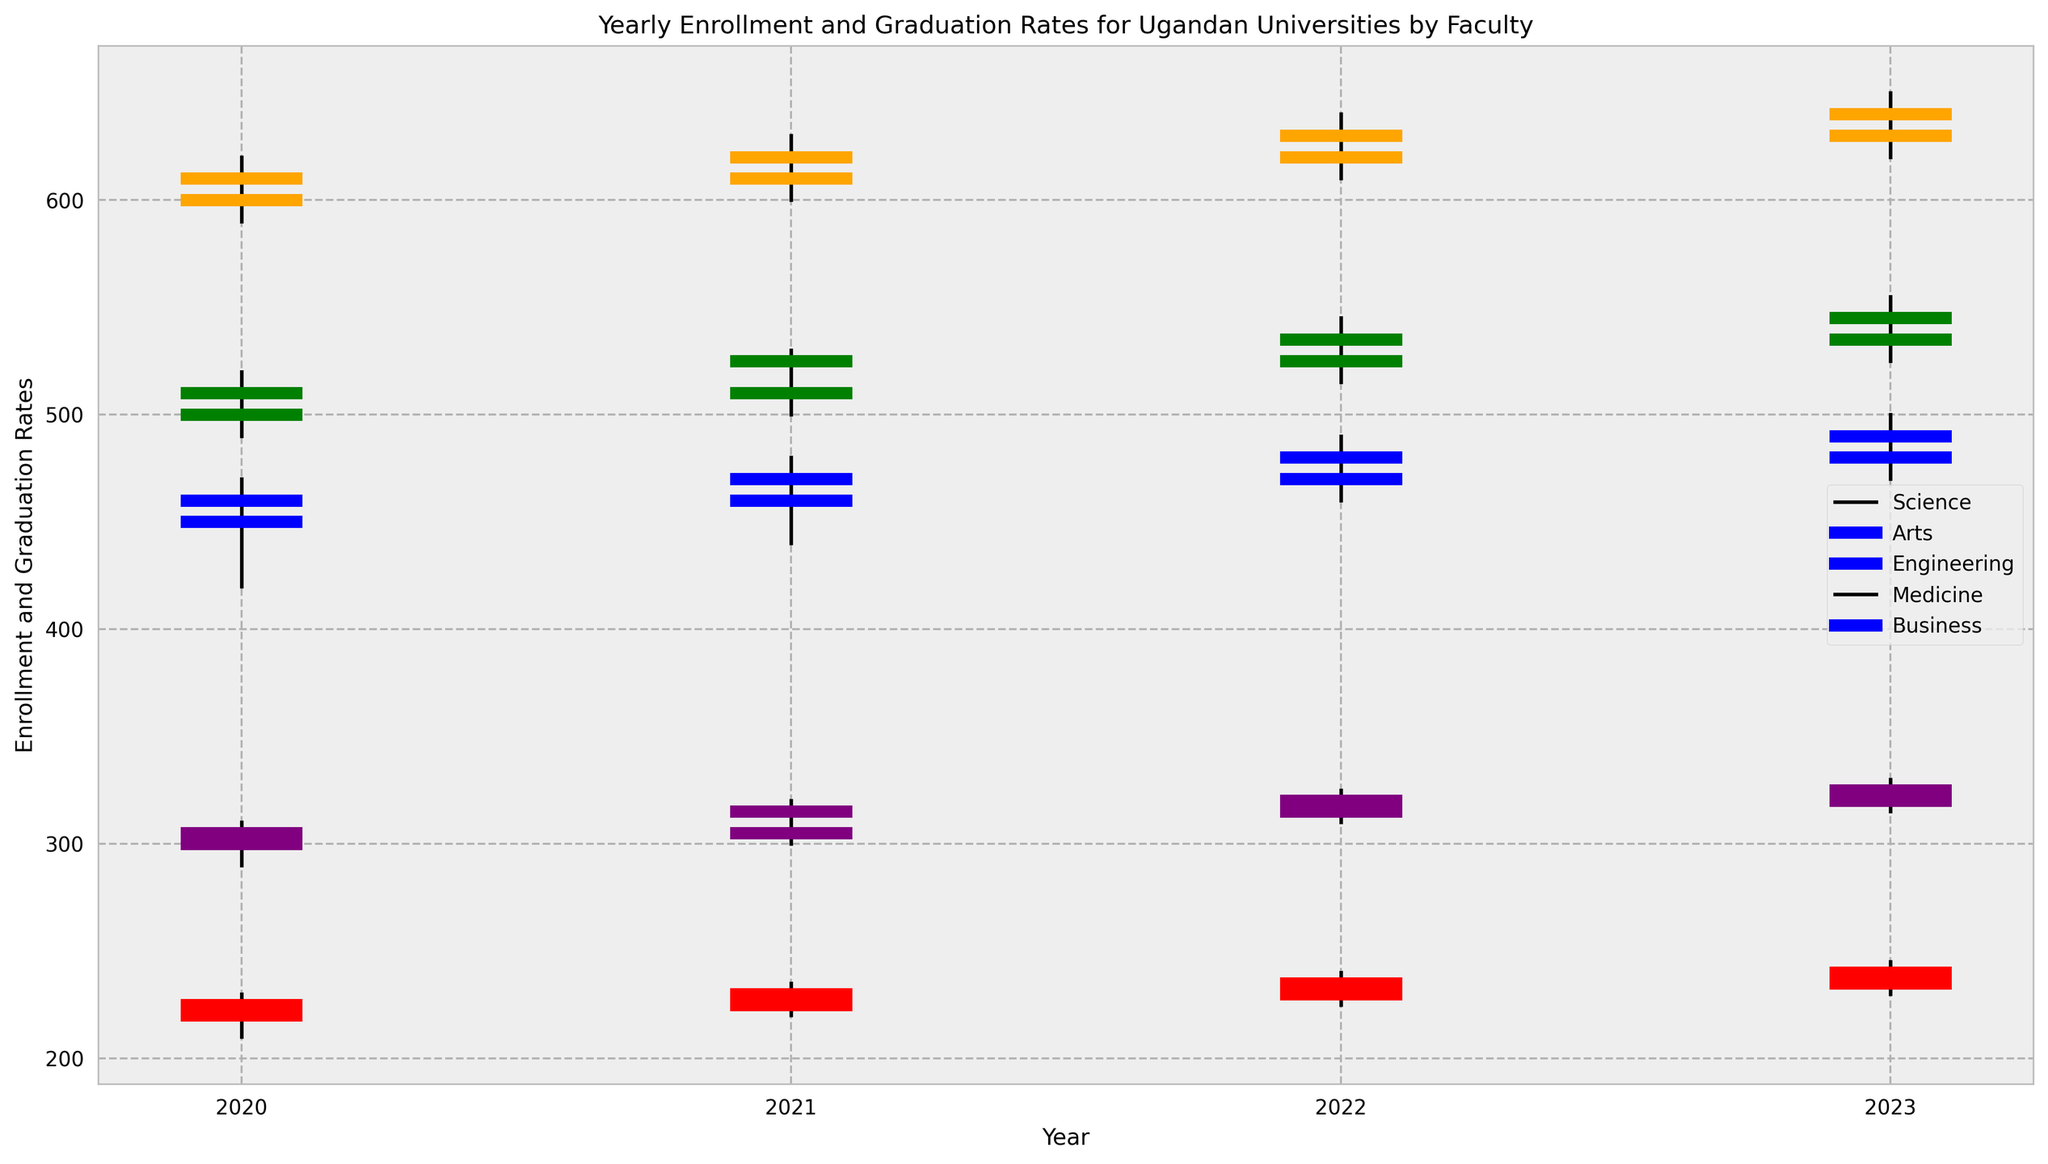What trend is observed in the enrollment and graduation rates for the Science faculty from 2020 to 2023? The Science faculty's enrollment and graduation rates consistently increased from 450 in 2020 to 490 in 2023. This can be seen as the opening values for each year are progressively higher.
Answer: Increasing trend Which faculty had the highest graduation rates in 2023? In 2023, the Business faculty had the highest graduation rates, as indicated by the highest closing value of 640.
Answer: Business How does the range between the highest and lowest values in 2021 compare between the Medicine and Engineering faculties? For the Medicine faculty, the range in 2021 is 235 - 220 = 15. For the Engineering faculty, it is 320 - 300 = 20. The range is greater for the Engineering faculty.
Answer: Engineering Which faculty had the lowest enrollment rate in 2022, and what was the rate? The Medicine faculty had the lowest enrollment rate in 2022, with an opening value of 230.
Answer: Medicine, 230 Is there any year where all faculties show an increase in the rate from opening to closing values? In 2021, all faculties showed an increase in rates from their opening to closing values based on the candlestick representation where the close is higher than the open.
Answer: 2021 Compare the maximum graduation rates in 2023 for the Arts and Engineering faculties. In 2023, the maximum graduation rate for the Arts faculty is 555, while for Engineering it is 330. The Arts faculty has a significantly higher maximum graduation rate.
Answer: Arts, 555 Which faculty had the most consistent rates between the high and low values in 2020? The Engineering faculty had the most consistent rates in 2020, with the smallest range between its high (310) and low (290) values, which amounts to a range of 20.
Answer: Engineering What is the average closing rate for the Business faculty from 2020 to 2023? The closing rates for the Business faculty are 610 (2020), 620 (2021), 630 (2022), and 640 (2023). The average is (610 + 620 + 630 + 640) / 4 = 625.
Answer: 625 Which year shows the highest enrollment for the Science faculty, and what is the numerical value? The highest enrollment for the Science faculty is in 2023, with an opening value of 480.
Answer: 2023, 480 Between 2020 and 2021, how did the graduation rates for the Arts faculty change? The graduation rates for the Arts faculty increased from a closing value of 510 in 2020 to 525 in 2021.
Answer: Increased 